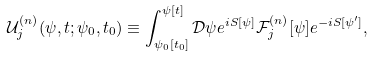Convert formula to latex. <formula><loc_0><loc_0><loc_500><loc_500>\mathcal { U } _ { j } ^ { ( n ) } ( \psi , t ; \psi _ { 0 } , t _ { 0 } ) \equiv \int _ { \psi _ { 0 } [ t _ { 0 } ] } ^ { \psi [ t ] } \mathcal { D } \psi e ^ { i S [ \psi ] } \mathcal { F } _ { j } ^ { ( n ) } [ \psi ] e ^ { - i S [ \psi ^ { \prime } ] } ,</formula> 